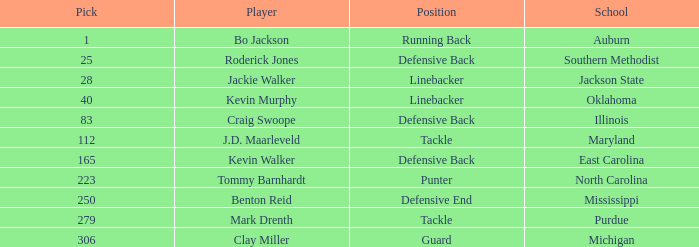Can you give me this table as a dict? {'header': ['Pick', 'Player', 'Position', 'School'], 'rows': [['1', 'Bo Jackson', 'Running Back', 'Auburn'], ['25', 'Roderick Jones', 'Defensive Back', 'Southern Methodist'], ['28', 'Jackie Walker', 'Linebacker', 'Jackson State'], ['40', 'Kevin Murphy', 'Linebacker', 'Oklahoma'], ['83', 'Craig Swoope', 'Defensive Back', 'Illinois'], ['112', 'J.D. Maarleveld', 'Tackle', 'Maryland'], ['165', 'Kevin Walker', 'Defensive Back', 'East Carolina'], ['223', 'Tommy Barnhardt', 'Punter', 'North Carolina'], ['250', 'Benton Reid', 'Defensive End', 'Mississippi'], ['279', 'Mark Drenth', 'Tackle', 'Purdue'], ['306', 'Clay Miller', 'Guard', 'Michigan']]} What is the highest pick for a player from auburn? 1.0. 